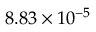<formula> <loc_0><loc_0><loc_500><loc_500>8 . 8 3 \times 1 0 ^ { - 5 }</formula> 